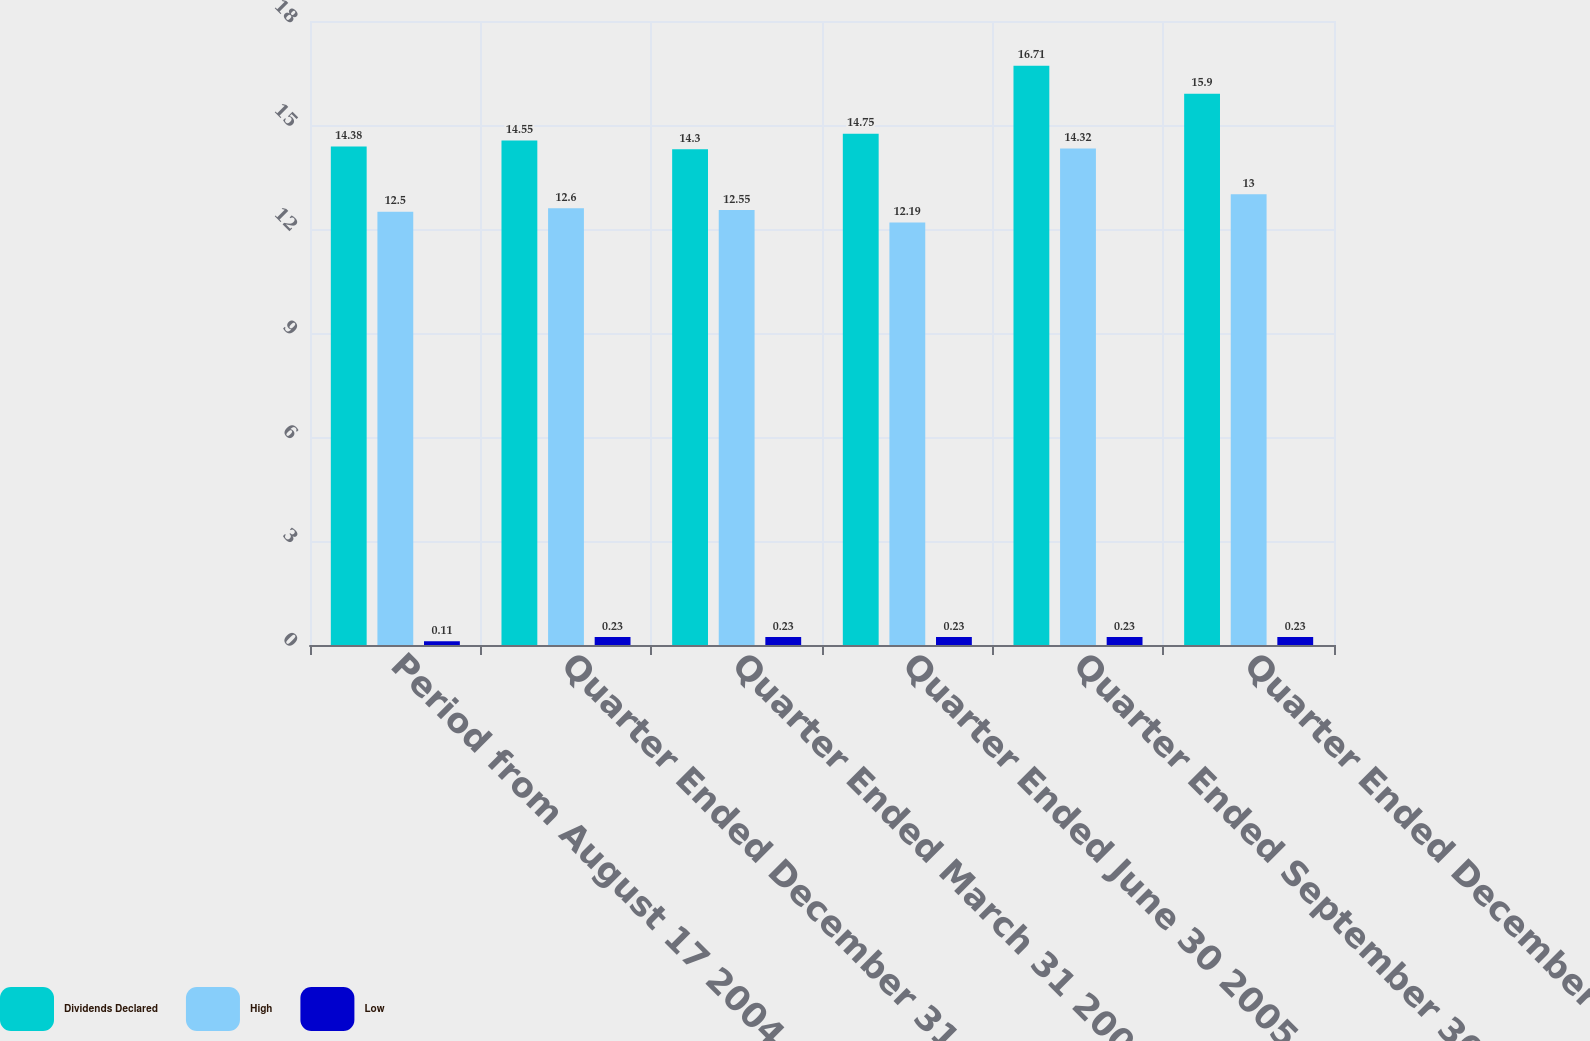Convert chart to OTSL. <chart><loc_0><loc_0><loc_500><loc_500><stacked_bar_chart><ecel><fcel>Period from August 17 2004 to<fcel>Quarter Ended December 31 2004<fcel>Quarter Ended March 31 2005<fcel>Quarter Ended June 30 2005<fcel>Quarter Ended September 30<fcel>Quarter Ended December 31 2005<nl><fcel>Dividends Declared<fcel>14.38<fcel>14.55<fcel>14.3<fcel>14.75<fcel>16.71<fcel>15.9<nl><fcel>High<fcel>12.5<fcel>12.6<fcel>12.55<fcel>12.19<fcel>14.32<fcel>13<nl><fcel>Low<fcel>0.11<fcel>0.23<fcel>0.23<fcel>0.23<fcel>0.23<fcel>0.23<nl></chart> 